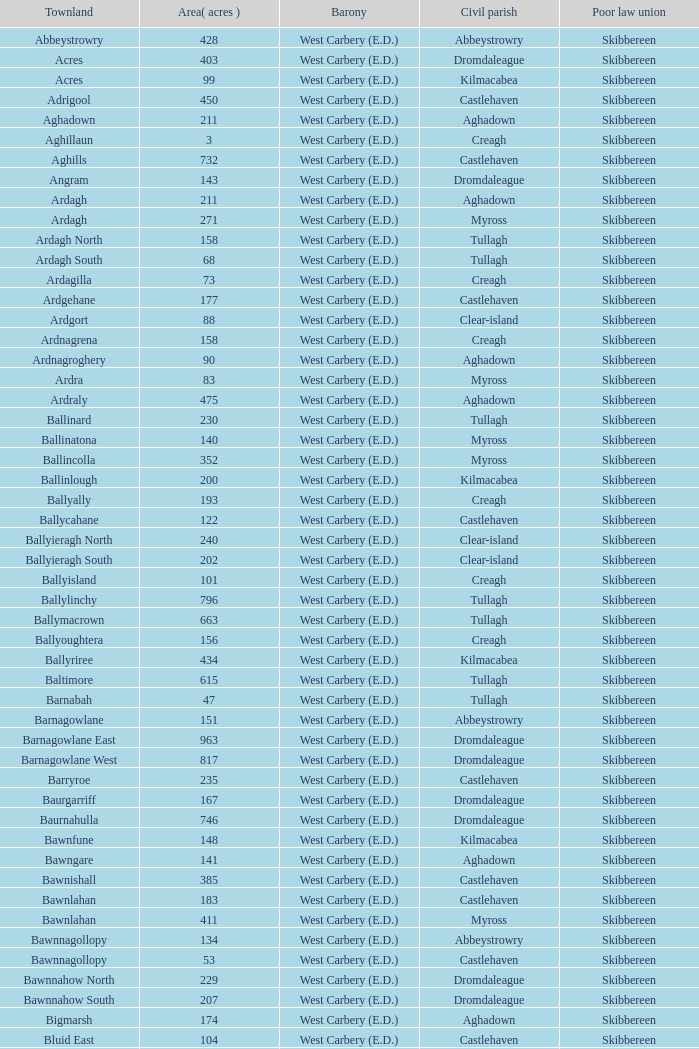What is the greatest area when the Poor Law Union is Skibbereen and the Civil Parish is Tullagh? 796.0. 